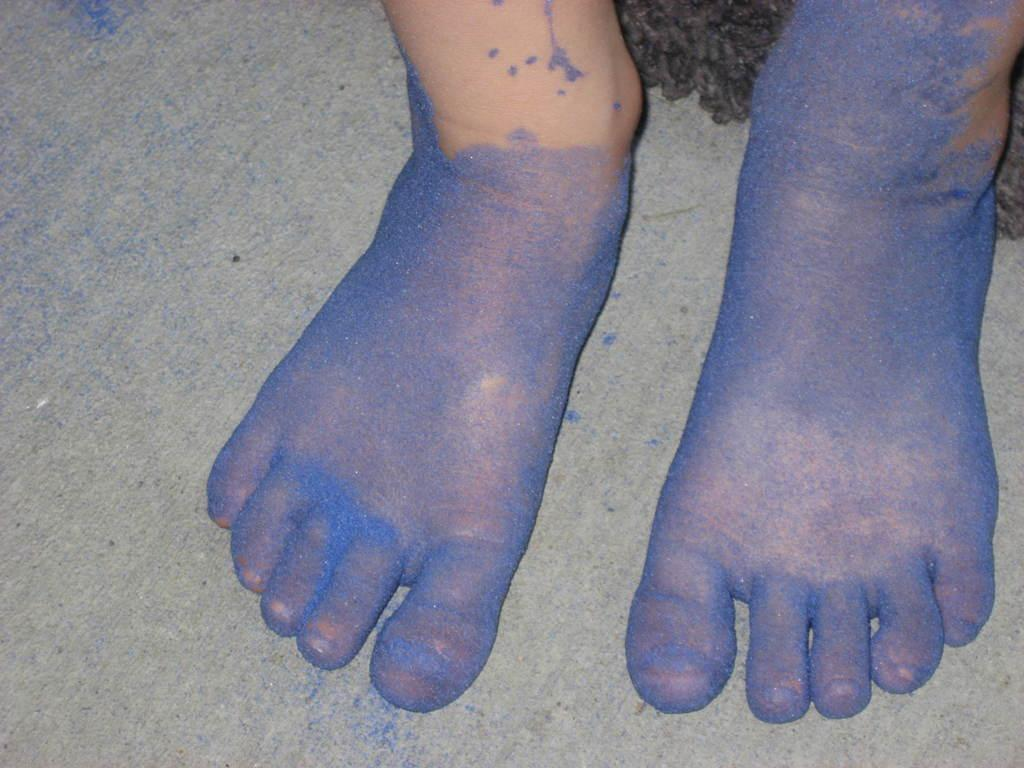What part of a person can be seen in the image? There are person's legs in the image. What color is the floor near the legs? The floor has a blue color visible near the legs. How many cakes are being prepared on the brake in the image? There is no brake or cakes present in the image; it only shows a person's legs and a blue floor. 